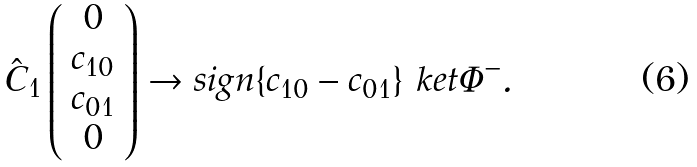Convert formula to latex. <formula><loc_0><loc_0><loc_500><loc_500>\hat { C } _ { 1 } \left ( \begin{array} { c } 0 \\ c _ { 1 0 } \\ c _ { 0 1 } \\ 0 \end{array} \right ) \rightarrow s i g n \{ c _ { 1 0 } - c _ { 0 1 } \} \ k e t { \Phi ^ { - } } .</formula> 